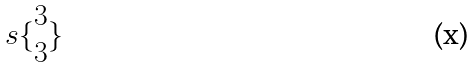<formula> <loc_0><loc_0><loc_500><loc_500>s \{ \begin{matrix} 3 \\ 3 \end{matrix} \}</formula> 